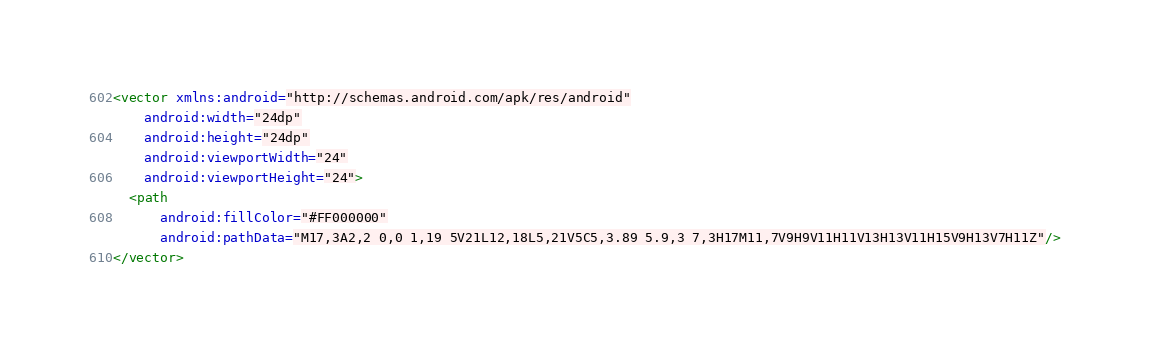Convert code to text. <code><loc_0><loc_0><loc_500><loc_500><_XML_><vector xmlns:android="http://schemas.android.com/apk/res/android"
    android:width="24dp"
    android:height="24dp"
    android:viewportWidth="24"
    android:viewportHeight="24">
  <path
      android:fillColor="#FF000000"
      android:pathData="M17,3A2,2 0,0 1,19 5V21L12,18L5,21V5C5,3.89 5.9,3 7,3H17M11,7V9H9V11H11V13H13V11H15V9H13V7H11Z"/>
</vector>
</code> 